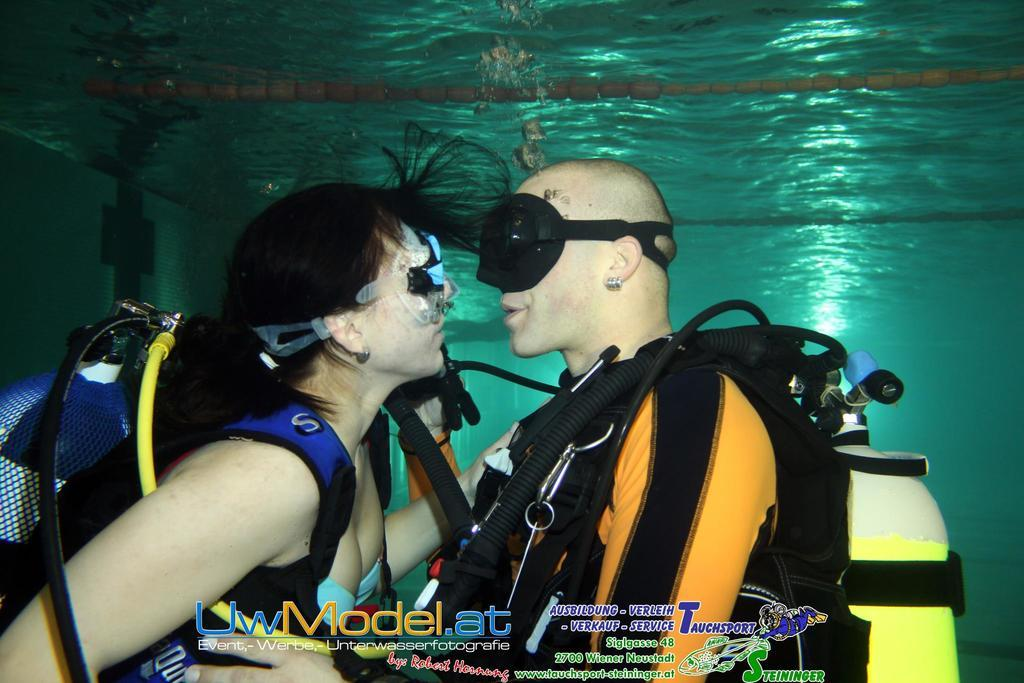Where is the image taken? The image is taken inside the water. How many people are in the image? There are two persons in the image. What are the persons wearing? The persons are wearing cylinders. Is there any text present in the image? Yes, there is text at the bottom of the image. What type of test is the boy conducting with his brother in the image? There is no boy or brother present in the image, and no test is being conducted. 